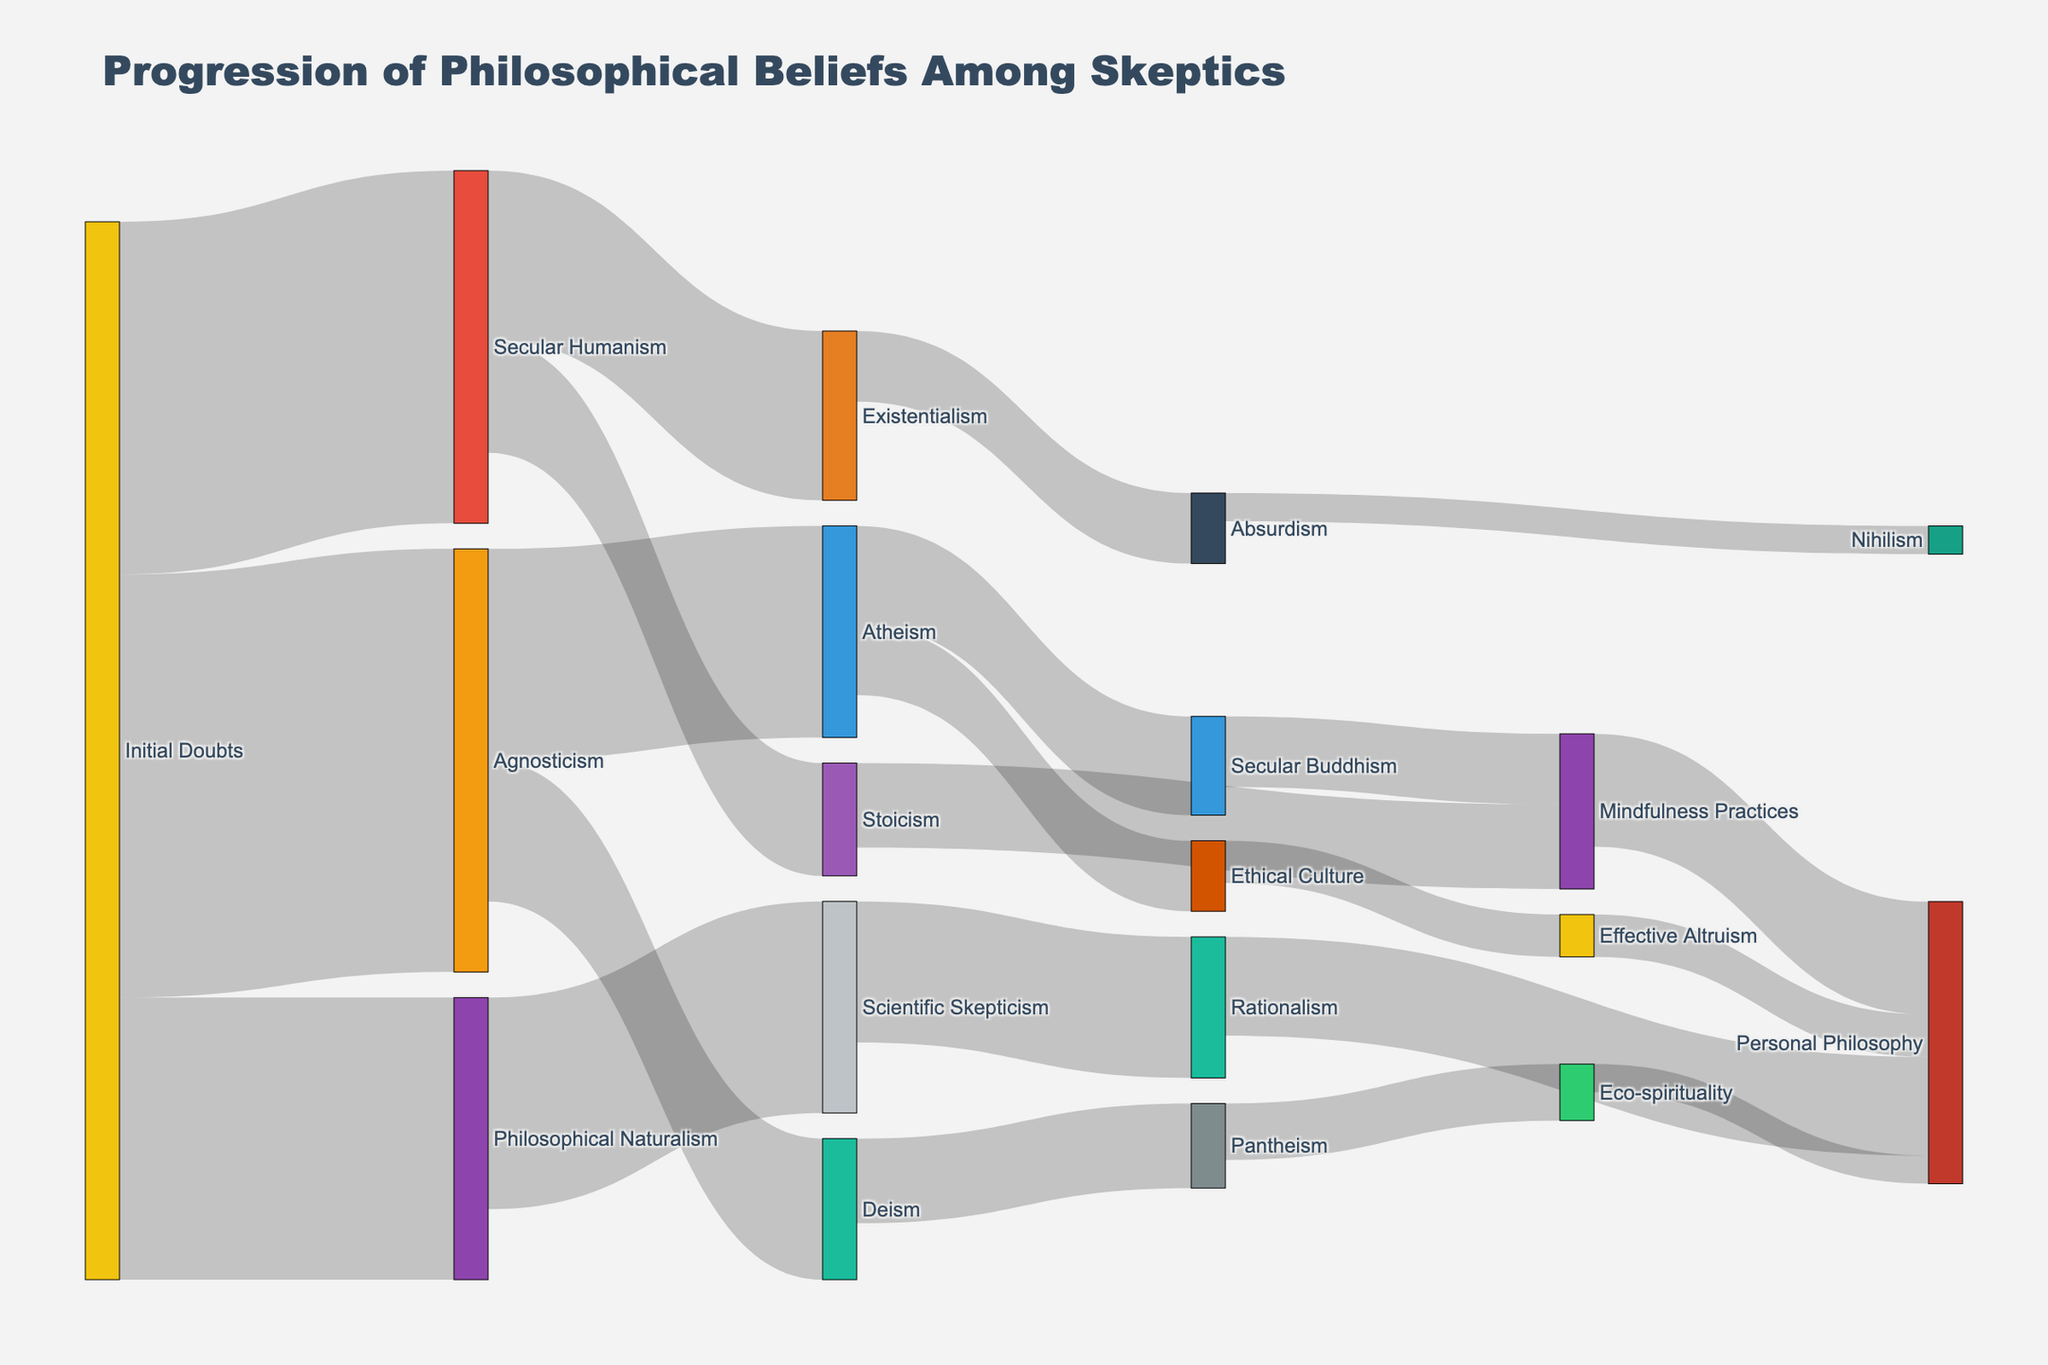How many skeptics start with Initial Doubts? To find the number of skeptics with Initial Doubts, sum the values of flows originating from Initial Doubts. These flows are to Agnosticism (30), Secular Humanism (25), and Philosophical Naturalism (20). Sum: 30 + 25 + 20 = 75.
Answer: 75 What is the most common belief following Initial Doubts? To determine this, look at the values of flows from Initial Doubts. The largest flow is to Agnosticism (30).
Answer: Agnosticism Which philosophical belief has the highest number of believers transitioning to Atheism? Examine the flows leading to Atheism and compare their values. Agnosticism has a flow of 15 to Atheism.
Answer: Agnosticism What is the combined total of skeptics following Secular Humanism and Philosophical Naturalism? Sum the initial flows going to Secular Humanism (25) and Philosophical Naturalism (20). Sum: 25 + 20 = 45.
Answer: 45 How many skeptics transition from Mindfulness Practices to Personal Philosophy? Identify the flow value from Mindfulness Practices to Personal Philosophy, which is 8.
Answer: 8 Compare the number of skeptics transitioning from Existentialism to Absurdism with those transitioning from Atheism to Secular Buddhism. Which is higher? Existentialism to Absurdism has a value of 5, while Atheism to Secular Buddhism has a value of 7. Compare 5 and 7.
Answer: Atheism to Secular Buddhism Which belief has the smallest flow to Personal Philosophy? Review the flows leading to Personal Philosophy: Mindfulness Practices (8), Rationalism (7), Effective Altruism (3), and Eco-spirituality (2). The smallest is from Eco-spirituality (2).
Answer: Eco-spirituality How many skeptics who followed Secular Humanism subsequently embraced Stoicism? Find the flow value from Secular Humanism to Stoicism, which is 8.
Answer: 8 What is the total number of skeptics transitioning from Deism? Sum the flows from Deism to Pantheism (6) and other beliefs if any but only one flow is here. Sum: 6.
Answer: 6 Which belief involves the highest number of unique subsequent transitions? Count the unique target beliefs for each source belief. Initial Doubts transitions to three different beliefs (Agnosticism, Secular Humanism, Philosophical Naturalism). Compare counts for all beliefs and note the belief with the maximum number. Initial Doubts has three unique transitions.
Answer: Initial Doubts 